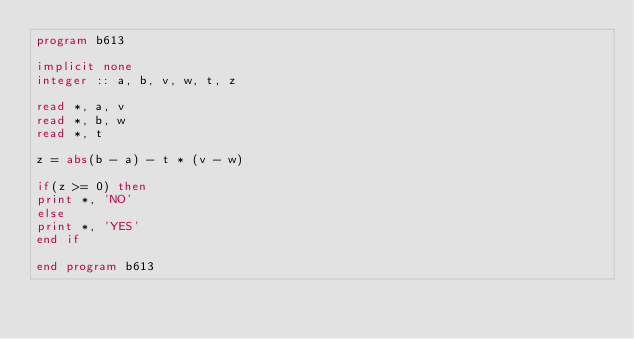<code> <loc_0><loc_0><loc_500><loc_500><_FORTRAN_>program b613
 
implicit none
integer :: a, b, v, w, t, z
 
read *, a, v
read *, b, w
read *, t
 
z = abs(b - a) - t * (v - w)
 
if(z >= 0) then
print *, 'NO'
else
print *, 'YES'
end if
 
end program b613</code> 